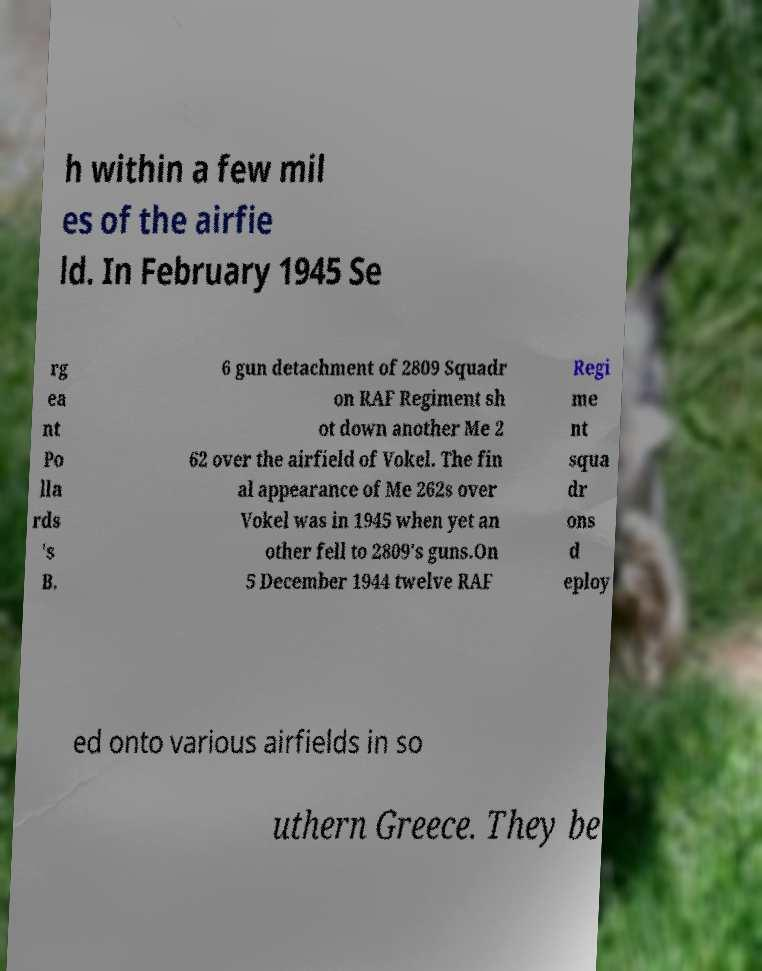Can you accurately transcribe the text from the provided image for me? h within a few mil es of the airfie ld. In February 1945 Se rg ea nt Po lla rds 's B. 6 gun detachment of 2809 Squadr on RAF Regiment sh ot down another Me 2 62 over the airfield of Vokel. The fin al appearance of Me 262s over Vokel was in 1945 when yet an other fell to 2809's guns.On 5 December 1944 twelve RAF Regi me nt squa dr ons d eploy ed onto various airfields in so uthern Greece. They be 